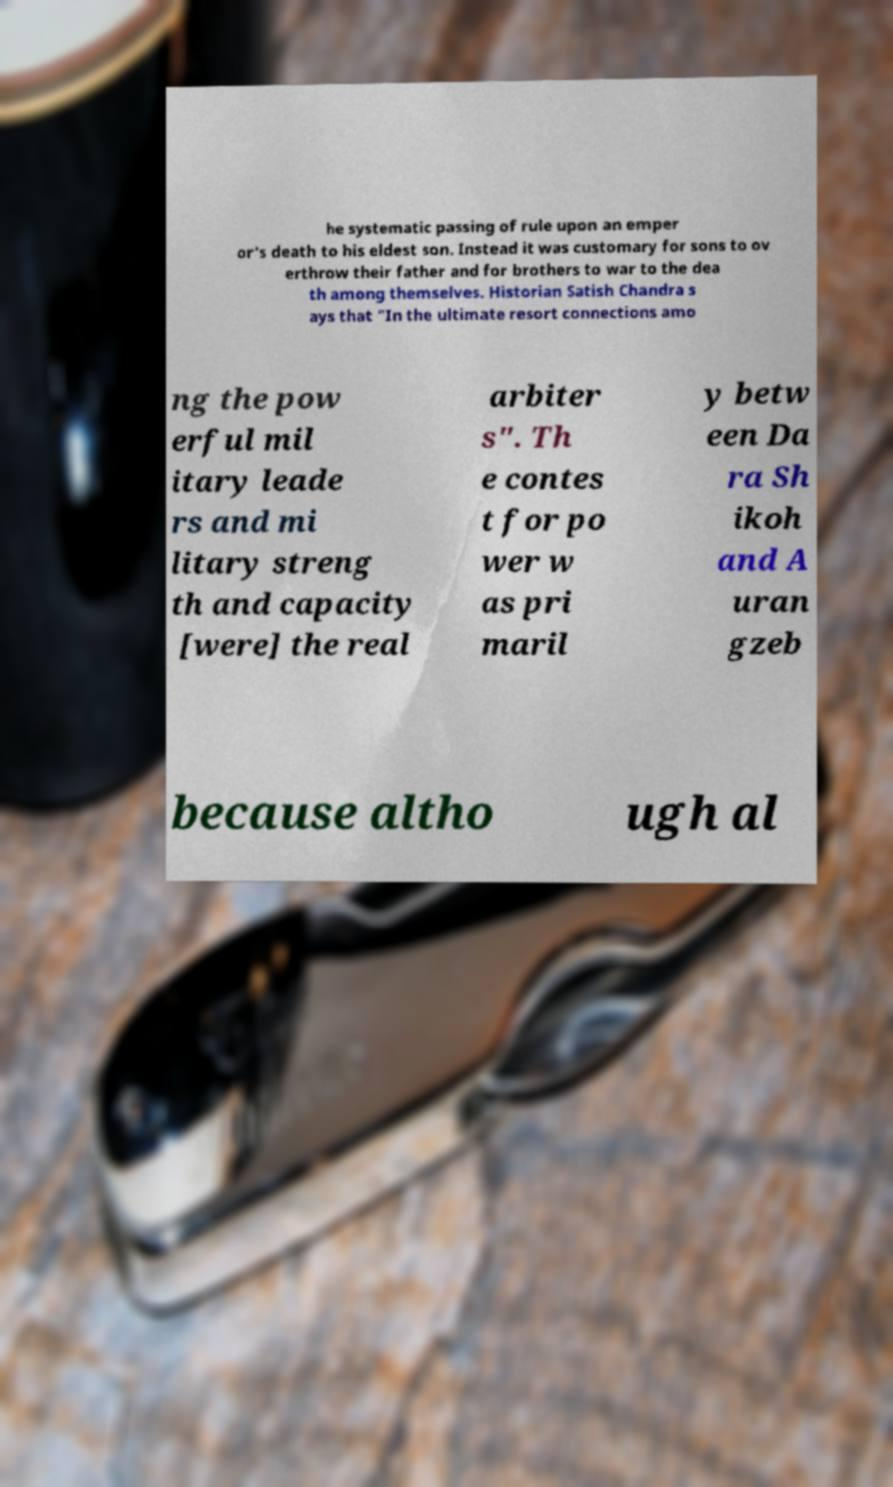Could you extract and type out the text from this image? he systematic passing of rule upon an emper or's death to his eldest son. Instead it was customary for sons to ov erthrow their father and for brothers to war to the dea th among themselves. Historian Satish Chandra s ays that "In the ultimate resort connections amo ng the pow erful mil itary leade rs and mi litary streng th and capacity [were] the real arbiter s". Th e contes t for po wer w as pri maril y betw een Da ra Sh ikoh and A uran gzeb because altho ugh al 